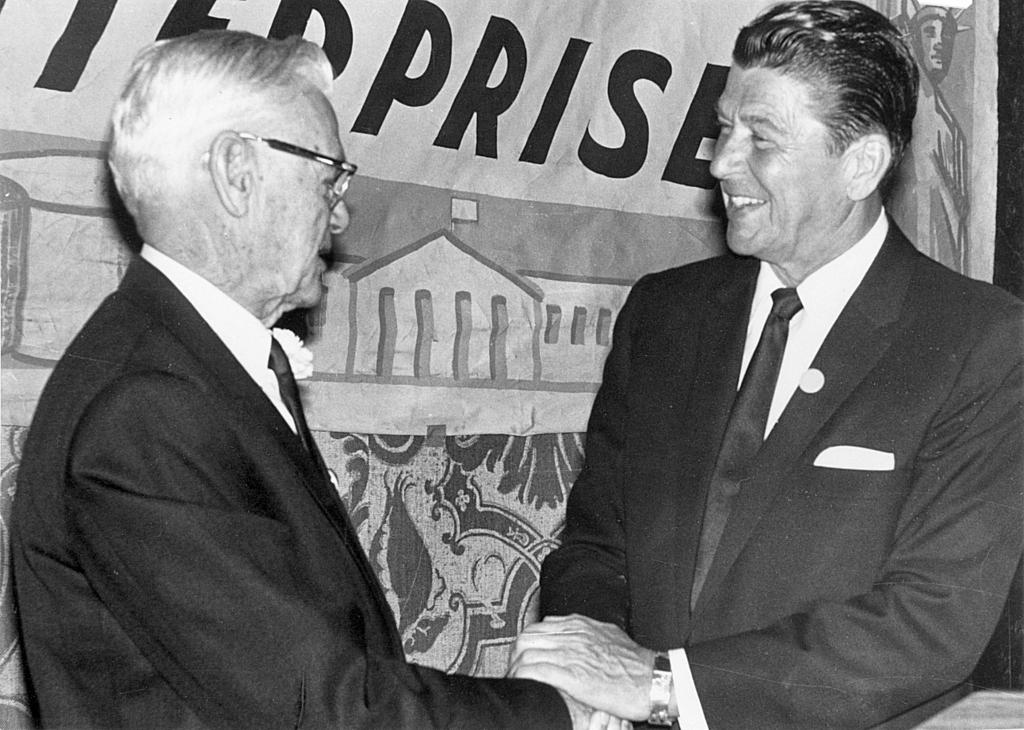What is the color scheme of the image? The image is black and white. How many men are in the front of the image? There are two men in the front of the image. What are the men doing in the image? The men are holding hands. What are the men wearing in the image? Both men are wearing suits. What can be seen behind the men in the image? There is a banner behind the men. Can you see any ghosts in the image? There are no ghosts present in the image. What type of ship is visible in the image? There is no ship present in the image. 